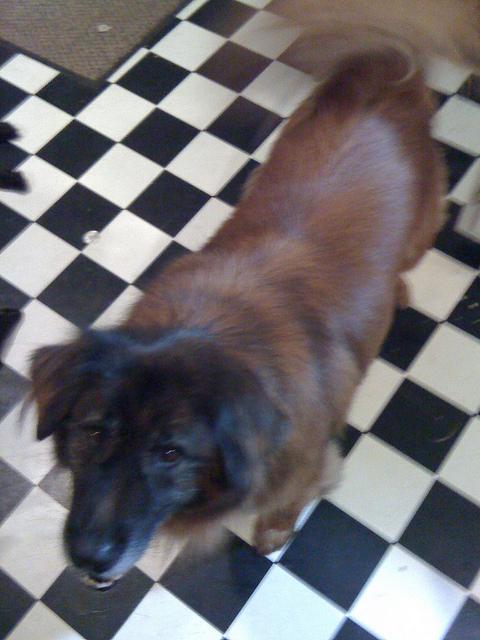Does the snout match the body?
Concise answer only. No. Is this a giant chessboard?
Concise answer only. No. What kind of dog is this?
Write a very short answer. Mutt. 